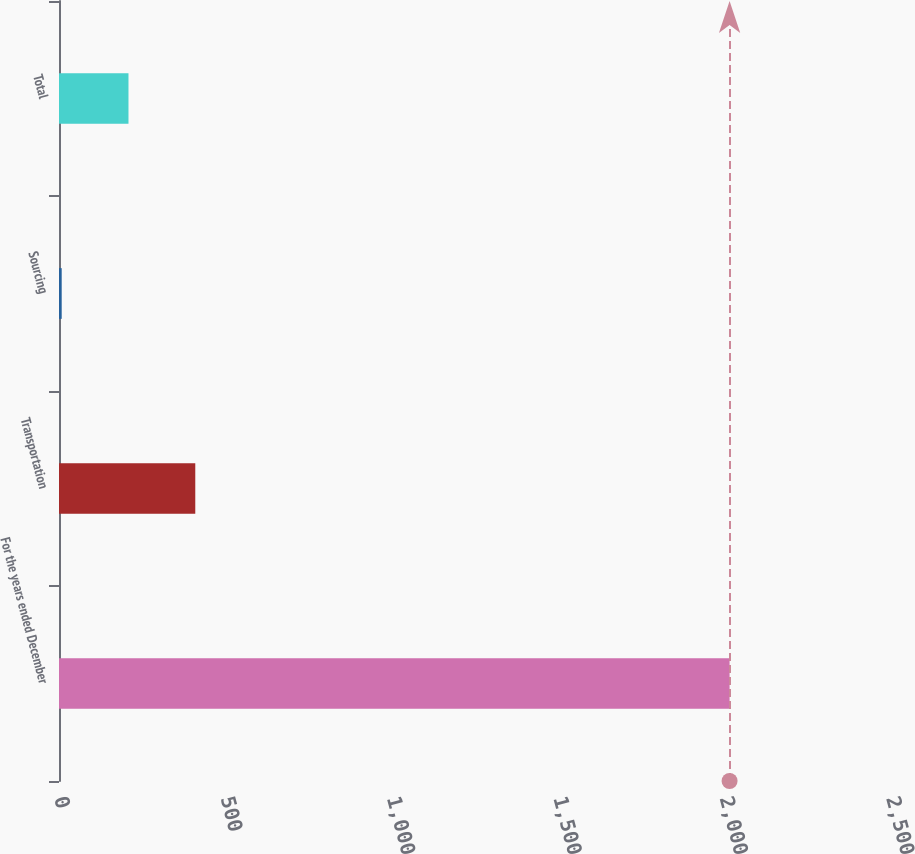<chart> <loc_0><loc_0><loc_500><loc_500><bar_chart><fcel>For the years ended December<fcel>Transportation<fcel>Sourcing<fcel>Total<nl><fcel>2015<fcel>409.48<fcel>8.1<fcel>208.79<nl></chart> 